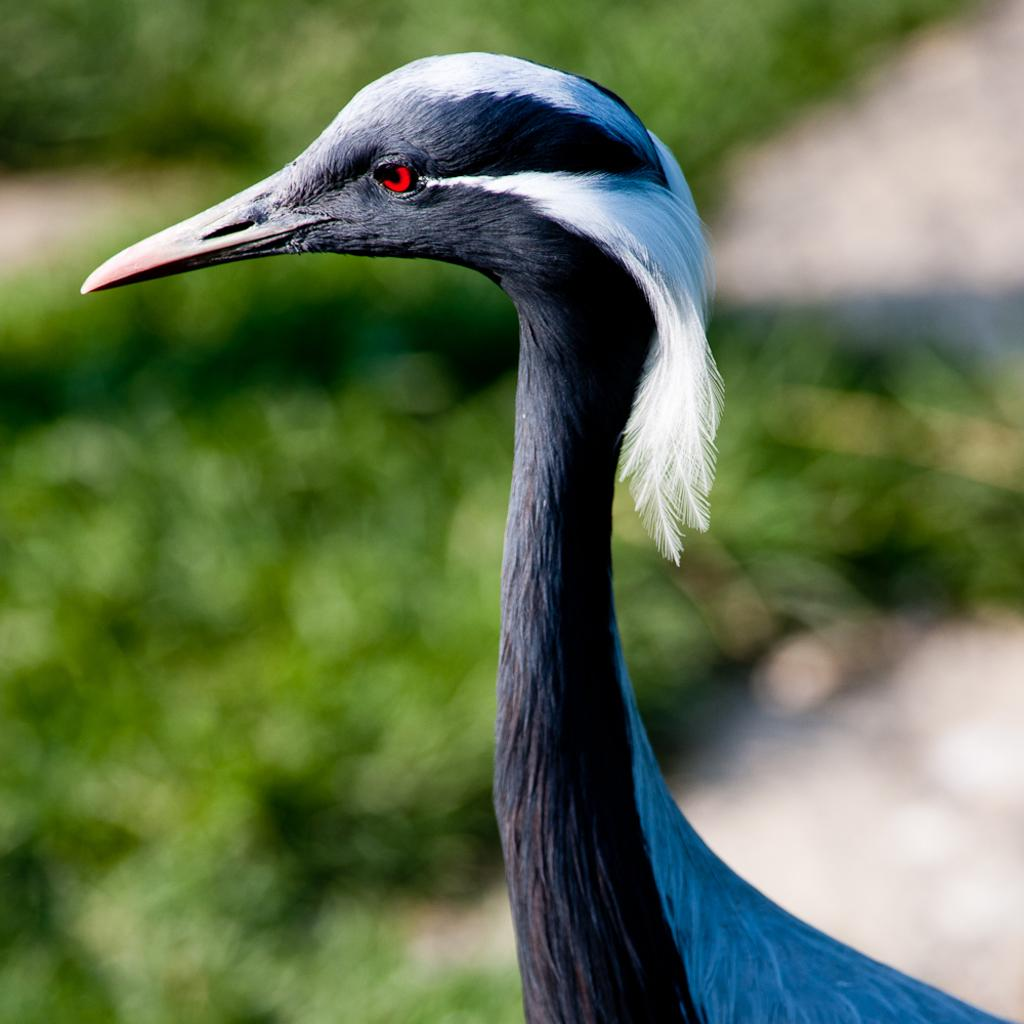What type of animal can be seen in the image? There is a bird in the image. What can be seen in the background of the image? There is greenery visible in the background of the image. How does the bird use a comb in the image? There is no comb present in the image, and therefore the bird cannot use one. 